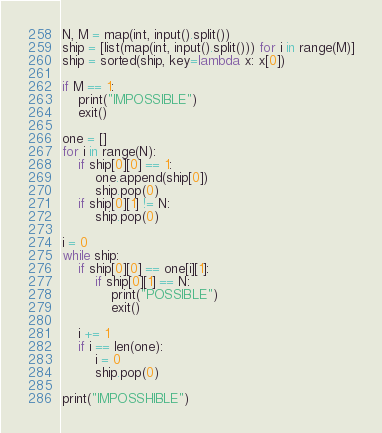<code> <loc_0><loc_0><loc_500><loc_500><_Python_>N, M = map(int, input().split())
ship = [list(map(int, input().split())) for i in range(M)]
ship = sorted(ship, key=lambda x: x[0])

if M == 1:
    print("IMPOSSIBLE")
    exit()

one = []
for i in range(N):
    if ship[0][0] == 1:
        one.append(ship[0])
        ship.pop(0)
    if ship[0][1] != N:
        ship.pop(0)

i = 0
while ship:
    if ship[0][0] == one[i][1]:
        if ship[0][1] == N:
            print("POSSIBLE")
            exit()

    i += 1
    if i == len(one):
        i = 0
        ship.pop(0)

print("IMPOSSHIBLE")
</code> 